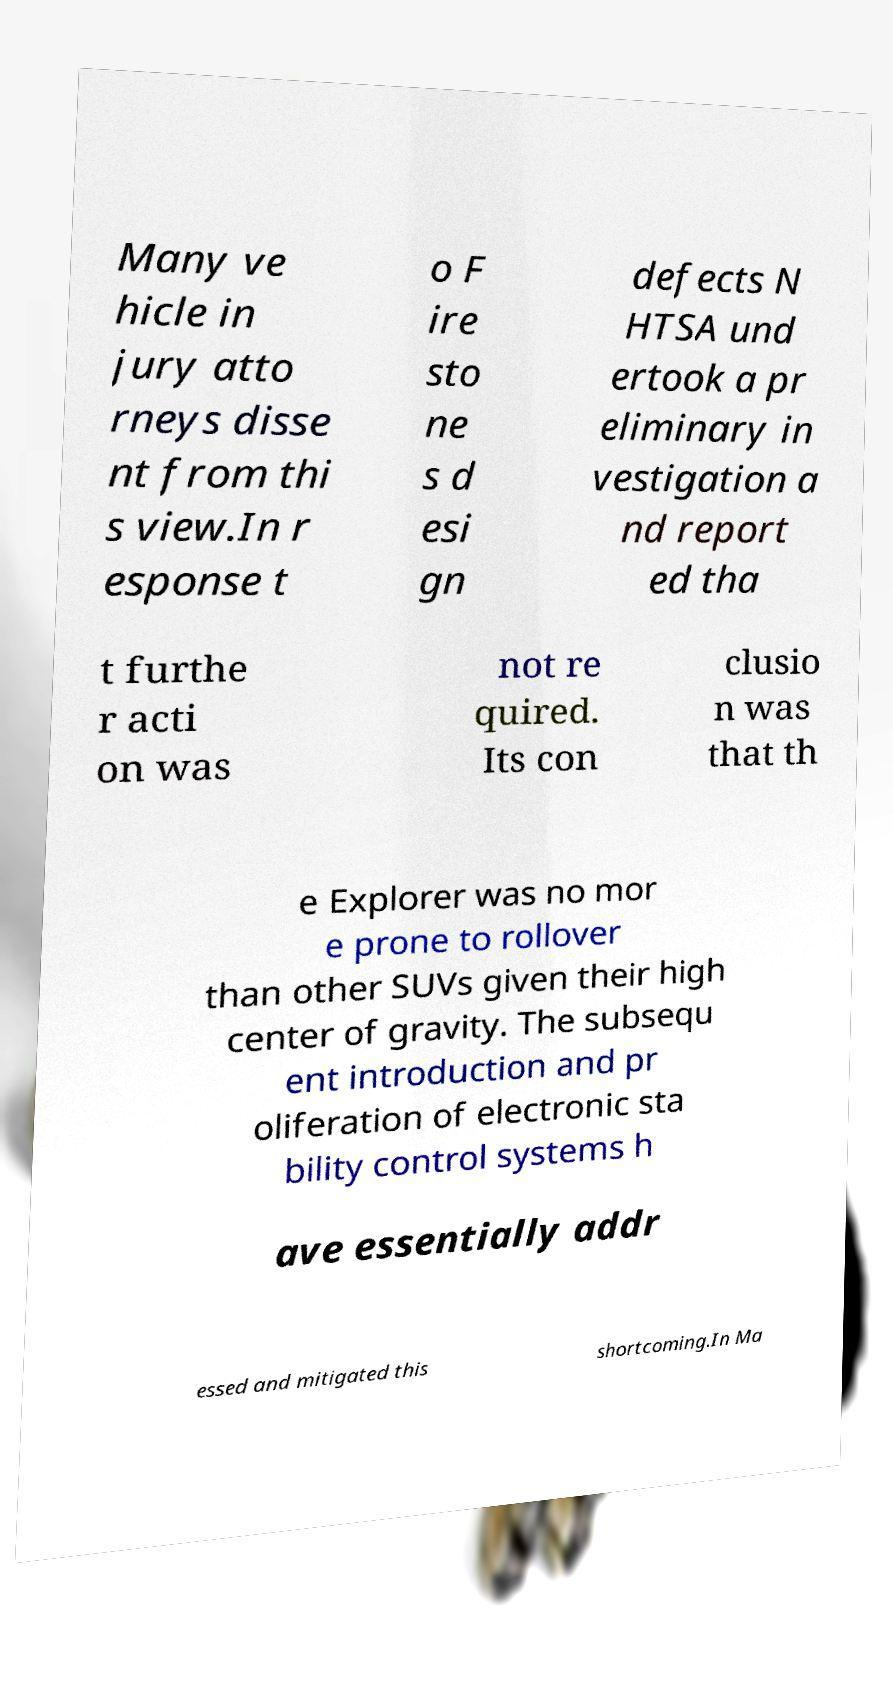Can you read and provide the text displayed in the image?This photo seems to have some interesting text. Can you extract and type it out for me? Many ve hicle in jury atto rneys disse nt from thi s view.In r esponse t o F ire sto ne s d esi gn defects N HTSA und ertook a pr eliminary in vestigation a nd report ed tha t furthe r acti on was not re quired. Its con clusio n was that th e Explorer was no mor e prone to rollover than other SUVs given their high center of gravity. The subsequ ent introduction and pr oliferation of electronic sta bility control systems h ave essentially addr essed and mitigated this shortcoming.In Ma 